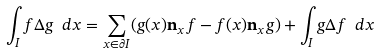Convert formula to latex. <formula><loc_0><loc_0><loc_500><loc_500>\int _ { I } f \Delta g \ d x = \sum _ { x \in \partial I } ( g ( x ) \mathbf n _ { x } f - f ( x ) \mathbf n _ { x } g ) + \int _ { I } g \Delta f \ d x</formula> 